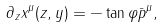<formula> <loc_0><loc_0><loc_500><loc_500>\partial _ { z } x ^ { \mu } ( z , y ) = - \tan \varphi \bar { p } ^ { \mu } ,</formula> 